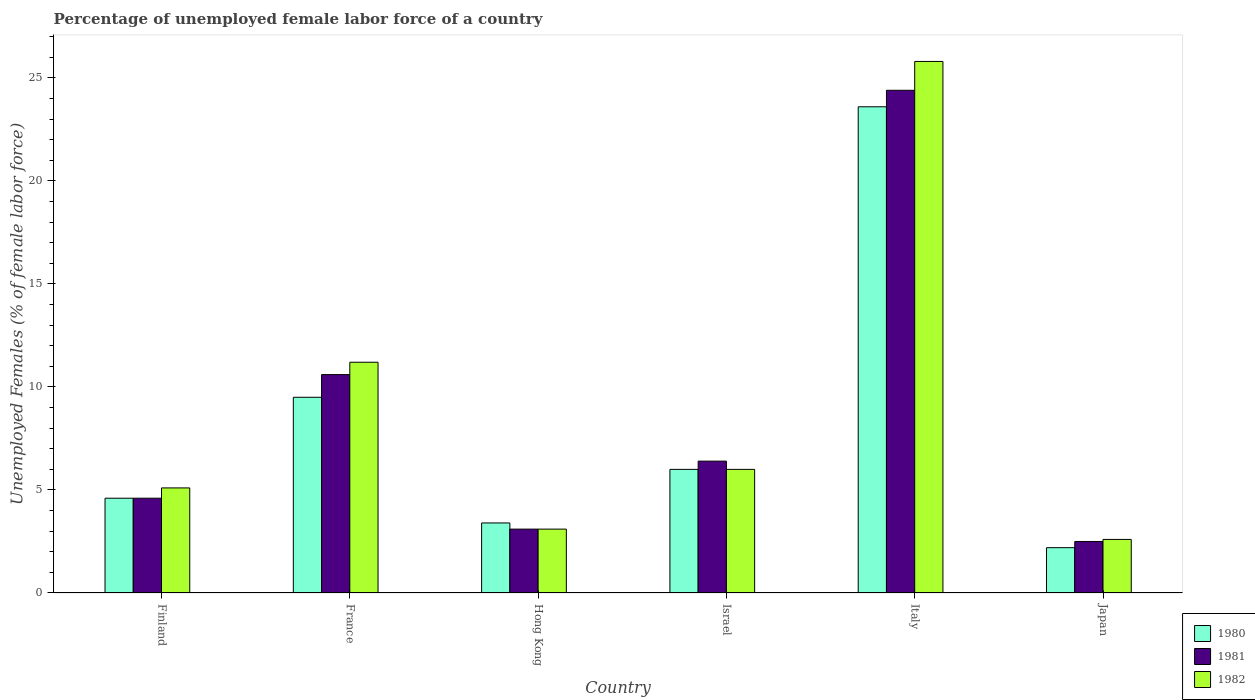How many bars are there on the 6th tick from the left?
Your answer should be compact. 3. In how many cases, is the number of bars for a given country not equal to the number of legend labels?
Give a very brief answer. 0. What is the percentage of unemployed female labor force in 1982 in Italy?
Offer a very short reply. 25.8. Across all countries, what is the maximum percentage of unemployed female labor force in 1982?
Provide a short and direct response. 25.8. What is the total percentage of unemployed female labor force in 1980 in the graph?
Your answer should be compact. 49.3. What is the difference between the percentage of unemployed female labor force in 1982 in Finland and that in Italy?
Offer a terse response. -20.7. What is the difference between the percentage of unemployed female labor force in 1980 in Israel and the percentage of unemployed female labor force in 1981 in Hong Kong?
Give a very brief answer. 2.9. What is the average percentage of unemployed female labor force in 1981 per country?
Provide a succinct answer. 8.6. What is the difference between the percentage of unemployed female labor force of/in 1981 and percentage of unemployed female labor force of/in 1980 in France?
Provide a short and direct response. 1.1. In how many countries, is the percentage of unemployed female labor force in 1981 greater than 24 %?
Offer a very short reply. 1. What is the ratio of the percentage of unemployed female labor force in 1980 in France to that in Hong Kong?
Give a very brief answer. 2.79. Is the difference between the percentage of unemployed female labor force in 1981 in Israel and Japan greater than the difference between the percentage of unemployed female labor force in 1980 in Israel and Japan?
Give a very brief answer. Yes. What is the difference between the highest and the second highest percentage of unemployed female labor force in 1982?
Give a very brief answer. 14.6. What is the difference between the highest and the lowest percentage of unemployed female labor force in 1982?
Give a very brief answer. 23.2. Is the sum of the percentage of unemployed female labor force in 1982 in Finland and Israel greater than the maximum percentage of unemployed female labor force in 1981 across all countries?
Make the answer very short. No. What does the 1st bar from the right in Japan represents?
Offer a terse response. 1982. Are all the bars in the graph horizontal?
Make the answer very short. No. Does the graph contain any zero values?
Ensure brevity in your answer.  No. Does the graph contain grids?
Provide a short and direct response. No. How many legend labels are there?
Provide a short and direct response. 3. What is the title of the graph?
Ensure brevity in your answer.  Percentage of unemployed female labor force of a country. What is the label or title of the Y-axis?
Make the answer very short. Unemployed Females (% of female labor force). What is the Unemployed Females (% of female labor force) of 1980 in Finland?
Offer a terse response. 4.6. What is the Unemployed Females (% of female labor force) in 1981 in Finland?
Make the answer very short. 4.6. What is the Unemployed Females (% of female labor force) in 1982 in Finland?
Your answer should be compact. 5.1. What is the Unemployed Females (% of female labor force) in 1981 in France?
Ensure brevity in your answer.  10.6. What is the Unemployed Females (% of female labor force) of 1982 in France?
Provide a short and direct response. 11.2. What is the Unemployed Females (% of female labor force) of 1980 in Hong Kong?
Give a very brief answer. 3.4. What is the Unemployed Females (% of female labor force) of 1981 in Hong Kong?
Offer a terse response. 3.1. What is the Unemployed Females (% of female labor force) in 1982 in Hong Kong?
Provide a short and direct response. 3.1. What is the Unemployed Females (% of female labor force) in 1980 in Israel?
Make the answer very short. 6. What is the Unemployed Females (% of female labor force) in 1981 in Israel?
Provide a succinct answer. 6.4. What is the Unemployed Females (% of female labor force) in 1982 in Israel?
Your answer should be very brief. 6. What is the Unemployed Females (% of female labor force) in 1980 in Italy?
Offer a terse response. 23.6. What is the Unemployed Females (% of female labor force) in 1981 in Italy?
Ensure brevity in your answer.  24.4. What is the Unemployed Females (% of female labor force) in 1982 in Italy?
Give a very brief answer. 25.8. What is the Unemployed Females (% of female labor force) in 1980 in Japan?
Offer a terse response. 2.2. What is the Unemployed Females (% of female labor force) of 1982 in Japan?
Your answer should be very brief. 2.6. Across all countries, what is the maximum Unemployed Females (% of female labor force) of 1980?
Your answer should be compact. 23.6. Across all countries, what is the maximum Unemployed Females (% of female labor force) in 1981?
Provide a short and direct response. 24.4. Across all countries, what is the maximum Unemployed Females (% of female labor force) in 1982?
Make the answer very short. 25.8. Across all countries, what is the minimum Unemployed Females (% of female labor force) of 1980?
Offer a terse response. 2.2. Across all countries, what is the minimum Unemployed Females (% of female labor force) in 1981?
Ensure brevity in your answer.  2.5. Across all countries, what is the minimum Unemployed Females (% of female labor force) in 1982?
Keep it short and to the point. 2.6. What is the total Unemployed Females (% of female labor force) in 1980 in the graph?
Offer a terse response. 49.3. What is the total Unemployed Females (% of female labor force) of 1981 in the graph?
Ensure brevity in your answer.  51.6. What is the total Unemployed Females (% of female labor force) in 1982 in the graph?
Provide a succinct answer. 53.8. What is the difference between the Unemployed Females (% of female labor force) in 1980 in Finland and that in France?
Your answer should be very brief. -4.9. What is the difference between the Unemployed Females (% of female labor force) in 1982 in Finland and that in France?
Your answer should be very brief. -6.1. What is the difference between the Unemployed Females (% of female labor force) in 1982 in Finland and that in Hong Kong?
Your answer should be compact. 2. What is the difference between the Unemployed Females (% of female labor force) of 1981 in Finland and that in Italy?
Provide a succinct answer. -19.8. What is the difference between the Unemployed Females (% of female labor force) in 1982 in Finland and that in Italy?
Provide a short and direct response. -20.7. What is the difference between the Unemployed Females (% of female labor force) in 1980 in Finland and that in Japan?
Provide a succinct answer. 2.4. What is the difference between the Unemployed Females (% of female labor force) in 1981 in Finland and that in Japan?
Provide a short and direct response. 2.1. What is the difference between the Unemployed Females (% of female labor force) in 1980 in France and that in Hong Kong?
Keep it short and to the point. 6.1. What is the difference between the Unemployed Females (% of female labor force) in 1981 in France and that in Hong Kong?
Your response must be concise. 7.5. What is the difference between the Unemployed Females (% of female labor force) in 1982 in France and that in Hong Kong?
Offer a terse response. 8.1. What is the difference between the Unemployed Females (% of female labor force) of 1980 in France and that in Israel?
Your answer should be very brief. 3.5. What is the difference between the Unemployed Females (% of female labor force) of 1980 in France and that in Italy?
Provide a short and direct response. -14.1. What is the difference between the Unemployed Females (% of female labor force) in 1981 in France and that in Italy?
Ensure brevity in your answer.  -13.8. What is the difference between the Unemployed Females (% of female labor force) of 1982 in France and that in Italy?
Keep it short and to the point. -14.6. What is the difference between the Unemployed Females (% of female labor force) of 1980 in France and that in Japan?
Provide a succinct answer. 7.3. What is the difference between the Unemployed Females (% of female labor force) in 1982 in France and that in Japan?
Your answer should be very brief. 8.6. What is the difference between the Unemployed Females (% of female labor force) in 1980 in Hong Kong and that in Israel?
Your answer should be compact. -2.6. What is the difference between the Unemployed Females (% of female labor force) in 1982 in Hong Kong and that in Israel?
Give a very brief answer. -2.9. What is the difference between the Unemployed Females (% of female labor force) in 1980 in Hong Kong and that in Italy?
Offer a very short reply. -20.2. What is the difference between the Unemployed Females (% of female labor force) in 1981 in Hong Kong and that in Italy?
Provide a succinct answer. -21.3. What is the difference between the Unemployed Females (% of female labor force) of 1982 in Hong Kong and that in Italy?
Give a very brief answer. -22.7. What is the difference between the Unemployed Females (% of female labor force) of 1981 in Hong Kong and that in Japan?
Offer a very short reply. 0.6. What is the difference between the Unemployed Females (% of female labor force) in 1982 in Hong Kong and that in Japan?
Provide a short and direct response. 0.5. What is the difference between the Unemployed Females (% of female labor force) of 1980 in Israel and that in Italy?
Your answer should be very brief. -17.6. What is the difference between the Unemployed Females (% of female labor force) in 1982 in Israel and that in Italy?
Give a very brief answer. -19.8. What is the difference between the Unemployed Females (% of female labor force) of 1980 in Israel and that in Japan?
Provide a succinct answer. 3.8. What is the difference between the Unemployed Females (% of female labor force) in 1981 in Israel and that in Japan?
Your answer should be very brief. 3.9. What is the difference between the Unemployed Females (% of female labor force) in 1980 in Italy and that in Japan?
Ensure brevity in your answer.  21.4. What is the difference between the Unemployed Females (% of female labor force) in 1981 in Italy and that in Japan?
Your answer should be compact. 21.9. What is the difference between the Unemployed Females (% of female labor force) in 1982 in Italy and that in Japan?
Offer a terse response. 23.2. What is the difference between the Unemployed Females (% of female labor force) of 1980 in Finland and the Unemployed Females (% of female labor force) of 1982 in Hong Kong?
Your answer should be very brief. 1.5. What is the difference between the Unemployed Females (% of female labor force) of 1981 in Finland and the Unemployed Females (% of female labor force) of 1982 in Hong Kong?
Provide a short and direct response. 1.5. What is the difference between the Unemployed Females (% of female labor force) of 1980 in Finland and the Unemployed Females (% of female labor force) of 1982 in Israel?
Give a very brief answer. -1.4. What is the difference between the Unemployed Females (% of female labor force) in 1980 in Finland and the Unemployed Females (% of female labor force) in 1981 in Italy?
Offer a terse response. -19.8. What is the difference between the Unemployed Females (% of female labor force) in 1980 in Finland and the Unemployed Females (% of female labor force) in 1982 in Italy?
Make the answer very short. -21.2. What is the difference between the Unemployed Females (% of female labor force) of 1981 in Finland and the Unemployed Females (% of female labor force) of 1982 in Italy?
Provide a short and direct response. -21.2. What is the difference between the Unemployed Females (% of female labor force) in 1981 in Finland and the Unemployed Females (% of female labor force) in 1982 in Japan?
Give a very brief answer. 2. What is the difference between the Unemployed Females (% of female labor force) in 1980 in France and the Unemployed Females (% of female labor force) in 1981 in Hong Kong?
Give a very brief answer. 6.4. What is the difference between the Unemployed Females (% of female labor force) in 1980 in France and the Unemployed Females (% of female labor force) in 1982 in Hong Kong?
Ensure brevity in your answer.  6.4. What is the difference between the Unemployed Females (% of female labor force) in 1980 in France and the Unemployed Females (% of female labor force) in 1982 in Israel?
Your answer should be very brief. 3.5. What is the difference between the Unemployed Females (% of female labor force) in 1980 in France and the Unemployed Females (% of female labor force) in 1981 in Italy?
Your answer should be very brief. -14.9. What is the difference between the Unemployed Females (% of female labor force) of 1980 in France and the Unemployed Females (% of female labor force) of 1982 in Italy?
Make the answer very short. -16.3. What is the difference between the Unemployed Females (% of female labor force) of 1981 in France and the Unemployed Females (% of female labor force) of 1982 in Italy?
Provide a succinct answer. -15.2. What is the difference between the Unemployed Females (% of female labor force) in 1980 in Hong Kong and the Unemployed Females (% of female labor force) in 1982 in Israel?
Your answer should be very brief. -2.6. What is the difference between the Unemployed Females (% of female labor force) in 1981 in Hong Kong and the Unemployed Females (% of female labor force) in 1982 in Israel?
Your answer should be very brief. -2.9. What is the difference between the Unemployed Females (% of female labor force) in 1980 in Hong Kong and the Unemployed Females (% of female labor force) in 1982 in Italy?
Your response must be concise. -22.4. What is the difference between the Unemployed Females (% of female labor force) of 1981 in Hong Kong and the Unemployed Females (% of female labor force) of 1982 in Italy?
Provide a succinct answer. -22.7. What is the difference between the Unemployed Females (% of female labor force) of 1980 in Hong Kong and the Unemployed Females (% of female labor force) of 1982 in Japan?
Give a very brief answer. 0.8. What is the difference between the Unemployed Females (% of female labor force) in 1980 in Israel and the Unemployed Females (% of female labor force) in 1981 in Italy?
Offer a terse response. -18.4. What is the difference between the Unemployed Females (% of female labor force) of 1980 in Israel and the Unemployed Females (% of female labor force) of 1982 in Italy?
Provide a short and direct response. -19.8. What is the difference between the Unemployed Females (% of female labor force) of 1981 in Israel and the Unemployed Females (% of female labor force) of 1982 in Italy?
Give a very brief answer. -19.4. What is the difference between the Unemployed Females (% of female labor force) of 1980 in Italy and the Unemployed Females (% of female labor force) of 1981 in Japan?
Offer a very short reply. 21.1. What is the difference between the Unemployed Females (% of female labor force) in 1980 in Italy and the Unemployed Females (% of female labor force) in 1982 in Japan?
Provide a succinct answer. 21. What is the difference between the Unemployed Females (% of female labor force) in 1981 in Italy and the Unemployed Females (% of female labor force) in 1982 in Japan?
Give a very brief answer. 21.8. What is the average Unemployed Females (% of female labor force) in 1980 per country?
Give a very brief answer. 8.22. What is the average Unemployed Females (% of female labor force) in 1982 per country?
Your response must be concise. 8.97. What is the difference between the Unemployed Females (% of female labor force) of 1980 and Unemployed Females (% of female labor force) of 1981 in Finland?
Provide a succinct answer. 0. What is the difference between the Unemployed Females (% of female labor force) of 1981 and Unemployed Females (% of female labor force) of 1982 in Finland?
Keep it short and to the point. -0.5. What is the difference between the Unemployed Females (% of female labor force) of 1980 and Unemployed Females (% of female labor force) of 1981 in France?
Your response must be concise. -1.1. What is the difference between the Unemployed Females (% of female labor force) in 1980 and Unemployed Females (% of female labor force) in 1982 in France?
Provide a succinct answer. -1.7. What is the difference between the Unemployed Females (% of female labor force) in 1981 and Unemployed Females (% of female labor force) in 1982 in France?
Provide a succinct answer. -0.6. What is the difference between the Unemployed Females (% of female labor force) of 1980 and Unemployed Females (% of female labor force) of 1981 in Italy?
Offer a terse response. -0.8. What is the difference between the Unemployed Females (% of female labor force) in 1981 and Unemployed Females (% of female labor force) in 1982 in Italy?
Make the answer very short. -1.4. What is the difference between the Unemployed Females (% of female labor force) of 1980 and Unemployed Females (% of female labor force) of 1982 in Japan?
Provide a succinct answer. -0.4. What is the ratio of the Unemployed Females (% of female labor force) in 1980 in Finland to that in France?
Provide a short and direct response. 0.48. What is the ratio of the Unemployed Females (% of female labor force) of 1981 in Finland to that in France?
Your answer should be compact. 0.43. What is the ratio of the Unemployed Females (% of female labor force) of 1982 in Finland to that in France?
Keep it short and to the point. 0.46. What is the ratio of the Unemployed Females (% of female labor force) in 1980 in Finland to that in Hong Kong?
Offer a very short reply. 1.35. What is the ratio of the Unemployed Females (% of female labor force) of 1981 in Finland to that in Hong Kong?
Provide a succinct answer. 1.48. What is the ratio of the Unemployed Females (% of female labor force) in 1982 in Finland to that in Hong Kong?
Your response must be concise. 1.65. What is the ratio of the Unemployed Females (% of female labor force) in 1980 in Finland to that in Israel?
Make the answer very short. 0.77. What is the ratio of the Unemployed Females (% of female labor force) in 1981 in Finland to that in Israel?
Keep it short and to the point. 0.72. What is the ratio of the Unemployed Females (% of female labor force) of 1980 in Finland to that in Italy?
Offer a terse response. 0.19. What is the ratio of the Unemployed Females (% of female labor force) in 1981 in Finland to that in Italy?
Provide a succinct answer. 0.19. What is the ratio of the Unemployed Females (% of female labor force) in 1982 in Finland to that in Italy?
Provide a succinct answer. 0.2. What is the ratio of the Unemployed Females (% of female labor force) of 1980 in Finland to that in Japan?
Ensure brevity in your answer.  2.09. What is the ratio of the Unemployed Females (% of female labor force) of 1981 in Finland to that in Japan?
Ensure brevity in your answer.  1.84. What is the ratio of the Unemployed Females (% of female labor force) in 1982 in Finland to that in Japan?
Ensure brevity in your answer.  1.96. What is the ratio of the Unemployed Females (% of female labor force) of 1980 in France to that in Hong Kong?
Your answer should be very brief. 2.79. What is the ratio of the Unemployed Females (% of female labor force) of 1981 in France to that in Hong Kong?
Provide a short and direct response. 3.42. What is the ratio of the Unemployed Females (% of female labor force) of 1982 in France to that in Hong Kong?
Your answer should be very brief. 3.61. What is the ratio of the Unemployed Females (% of female labor force) in 1980 in France to that in Israel?
Provide a short and direct response. 1.58. What is the ratio of the Unemployed Females (% of female labor force) of 1981 in France to that in Israel?
Make the answer very short. 1.66. What is the ratio of the Unemployed Females (% of female labor force) in 1982 in France to that in Israel?
Your answer should be very brief. 1.87. What is the ratio of the Unemployed Females (% of female labor force) of 1980 in France to that in Italy?
Keep it short and to the point. 0.4. What is the ratio of the Unemployed Females (% of female labor force) in 1981 in France to that in Italy?
Your answer should be very brief. 0.43. What is the ratio of the Unemployed Females (% of female labor force) in 1982 in France to that in Italy?
Give a very brief answer. 0.43. What is the ratio of the Unemployed Females (% of female labor force) in 1980 in France to that in Japan?
Make the answer very short. 4.32. What is the ratio of the Unemployed Females (% of female labor force) in 1981 in France to that in Japan?
Ensure brevity in your answer.  4.24. What is the ratio of the Unemployed Females (% of female labor force) in 1982 in France to that in Japan?
Your answer should be very brief. 4.31. What is the ratio of the Unemployed Females (% of female labor force) in 1980 in Hong Kong to that in Israel?
Keep it short and to the point. 0.57. What is the ratio of the Unemployed Females (% of female labor force) of 1981 in Hong Kong to that in Israel?
Your response must be concise. 0.48. What is the ratio of the Unemployed Females (% of female labor force) of 1982 in Hong Kong to that in Israel?
Provide a succinct answer. 0.52. What is the ratio of the Unemployed Females (% of female labor force) of 1980 in Hong Kong to that in Italy?
Offer a very short reply. 0.14. What is the ratio of the Unemployed Females (% of female labor force) of 1981 in Hong Kong to that in Italy?
Provide a short and direct response. 0.13. What is the ratio of the Unemployed Females (% of female labor force) in 1982 in Hong Kong to that in Italy?
Offer a terse response. 0.12. What is the ratio of the Unemployed Females (% of female labor force) in 1980 in Hong Kong to that in Japan?
Give a very brief answer. 1.55. What is the ratio of the Unemployed Females (% of female labor force) of 1981 in Hong Kong to that in Japan?
Offer a very short reply. 1.24. What is the ratio of the Unemployed Females (% of female labor force) of 1982 in Hong Kong to that in Japan?
Give a very brief answer. 1.19. What is the ratio of the Unemployed Females (% of female labor force) of 1980 in Israel to that in Italy?
Offer a terse response. 0.25. What is the ratio of the Unemployed Females (% of female labor force) in 1981 in Israel to that in Italy?
Give a very brief answer. 0.26. What is the ratio of the Unemployed Females (% of female labor force) of 1982 in Israel to that in Italy?
Offer a very short reply. 0.23. What is the ratio of the Unemployed Females (% of female labor force) of 1980 in Israel to that in Japan?
Ensure brevity in your answer.  2.73. What is the ratio of the Unemployed Females (% of female labor force) in 1981 in Israel to that in Japan?
Offer a terse response. 2.56. What is the ratio of the Unemployed Females (% of female labor force) in 1982 in Israel to that in Japan?
Your answer should be very brief. 2.31. What is the ratio of the Unemployed Females (% of female labor force) in 1980 in Italy to that in Japan?
Provide a succinct answer. 10.73. What is the ratio of the Unemployed Females (% of female labor force) of 1981 in Italy to that in Japan?
Make the answer very short. 9.76. What is the ratio of the Unemployed Females (% of female labor force) of 1982 in Italy to that in Japan?
Provide a succinct answer. 9.92. What is the difference between the highest and the second highest Unemployed Females (% of female labor force) in 1981?
Your response must be concise. 13.8. What is the difference between the highest and the lowest Unemployed Females (% of female labor force) in 1980?
Ensure brevity in your answer.  21.4. What is the difference between the highest and the lowest Unemployed Females (% of female labor force) in 1981?
Your answer should be very brief. 21.9. What is the difference between the highest and the lowest Unemployed Females (% of female labor force) in 1982?
Give a very brief answer. 23.2. 